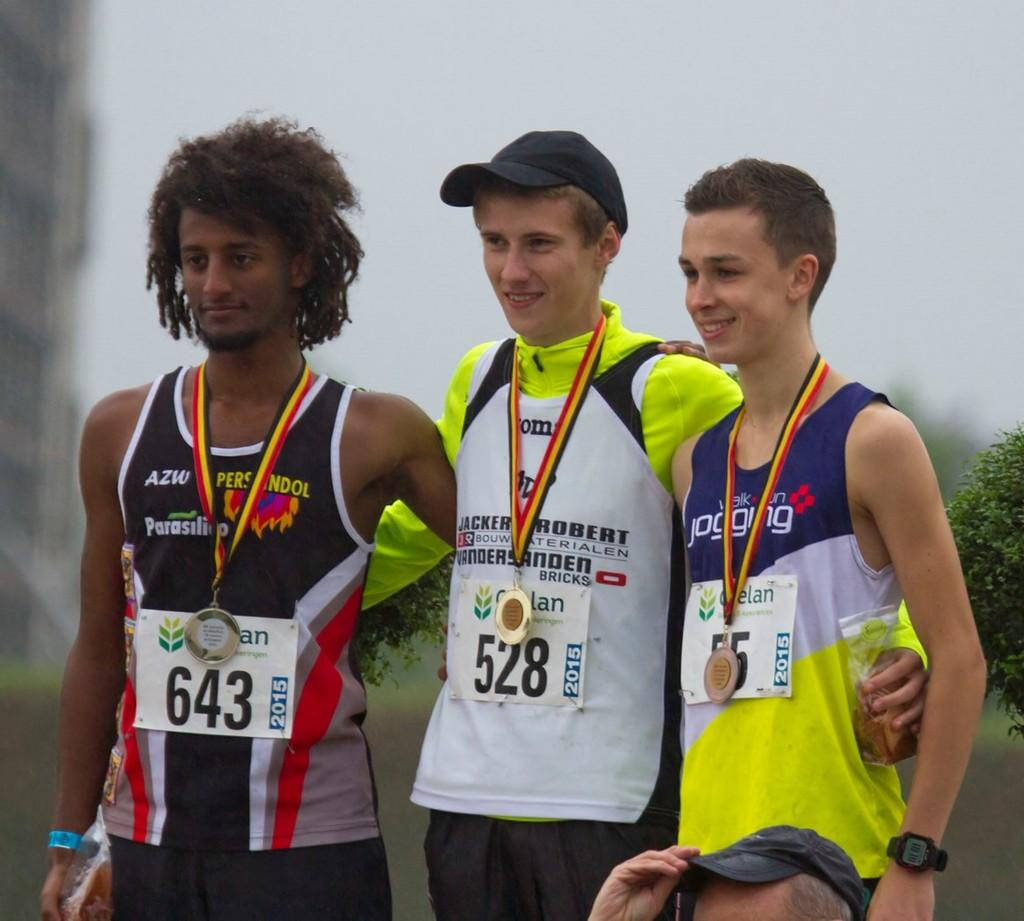Provide a one-sentence caption for the provided image. The boy in the bib with the number 528 won the gold medal. 